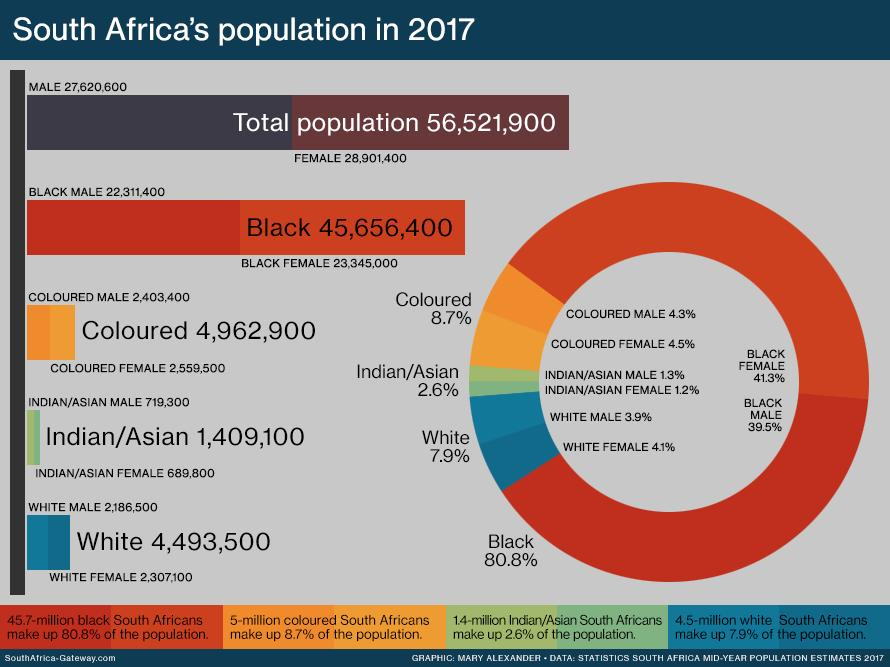Point out several critical features in this image. The combined percentage of black males and black females is 80.8%. According to the given data, the percentage of white and black taken together is 88.7%. According to the given data, the total number of colored individuals, whether male or female, is 8.8%. The combined percentage of Asian and colored individuals is 11.3%. According to the information provided, the percentage of Asian males and Asian females, taken together, is 2.5%. 